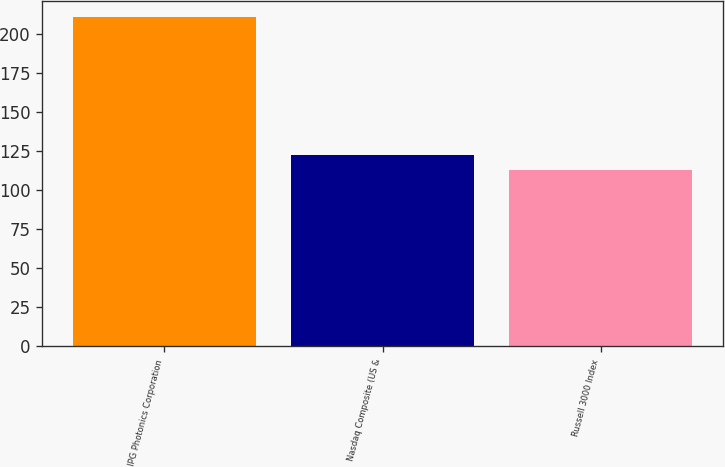Convert chart. <chart><loc_0><loc_0><loc_500><loc_500><bar_chart><fcel>IPG Photonics Corporation<fcel>Nasdaq Composite (US &<fcel>Russell 3000 Index<nl><fcel>210.78<fcel>122.72<fcel>112.93<nl></chart> 